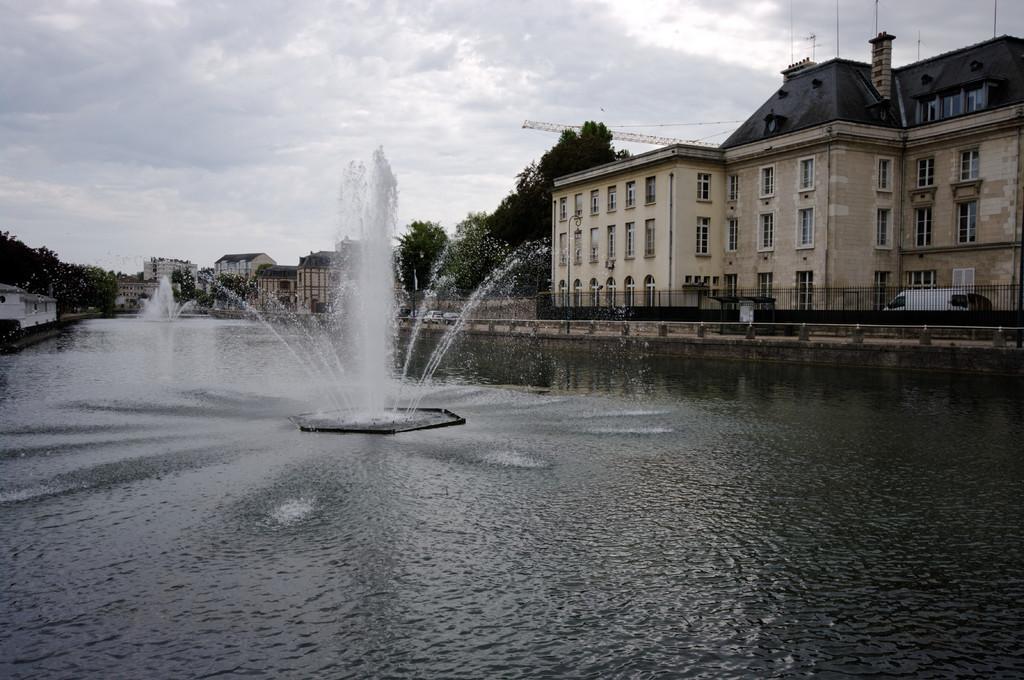In one or two sentences, can you explain what this image depicts? There is water. In the center there are fountains. On the sides there are buildings with windows. Also there are trees and railing. In the background there is sky. 